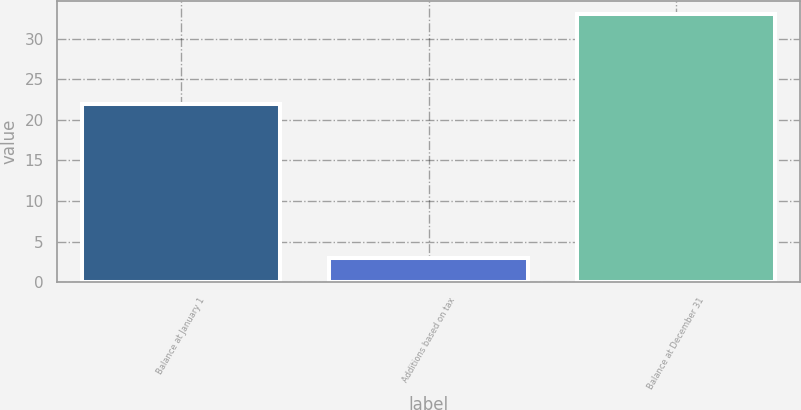Convert chart to OTSL. <chart><loc_0><loc_0><loc_500><loc_500><bar_chart><fcel>Balance at January 1<fcel>Additions based on tax<fcel>Balance at December 31<nl><fcel>22<fcel>3<fcel>33<nl></chart> 